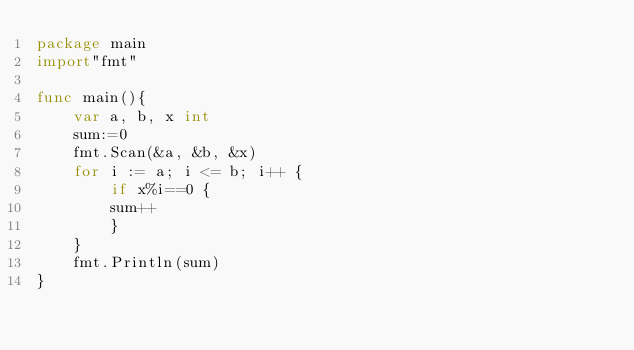Convert code to text. <code><loc_0><loc_0><loc_500><loc_500><_Go_>package main
import"fmt"

func main(){
    var a, b, x int
    sum:=0
    fmt.Scan(&a, &b, &x)
    for i := a; i <= b; i++ {
        if x%i==0 {
        sum++
        }
    }
    fmt.Println(sum)
}
</code> 